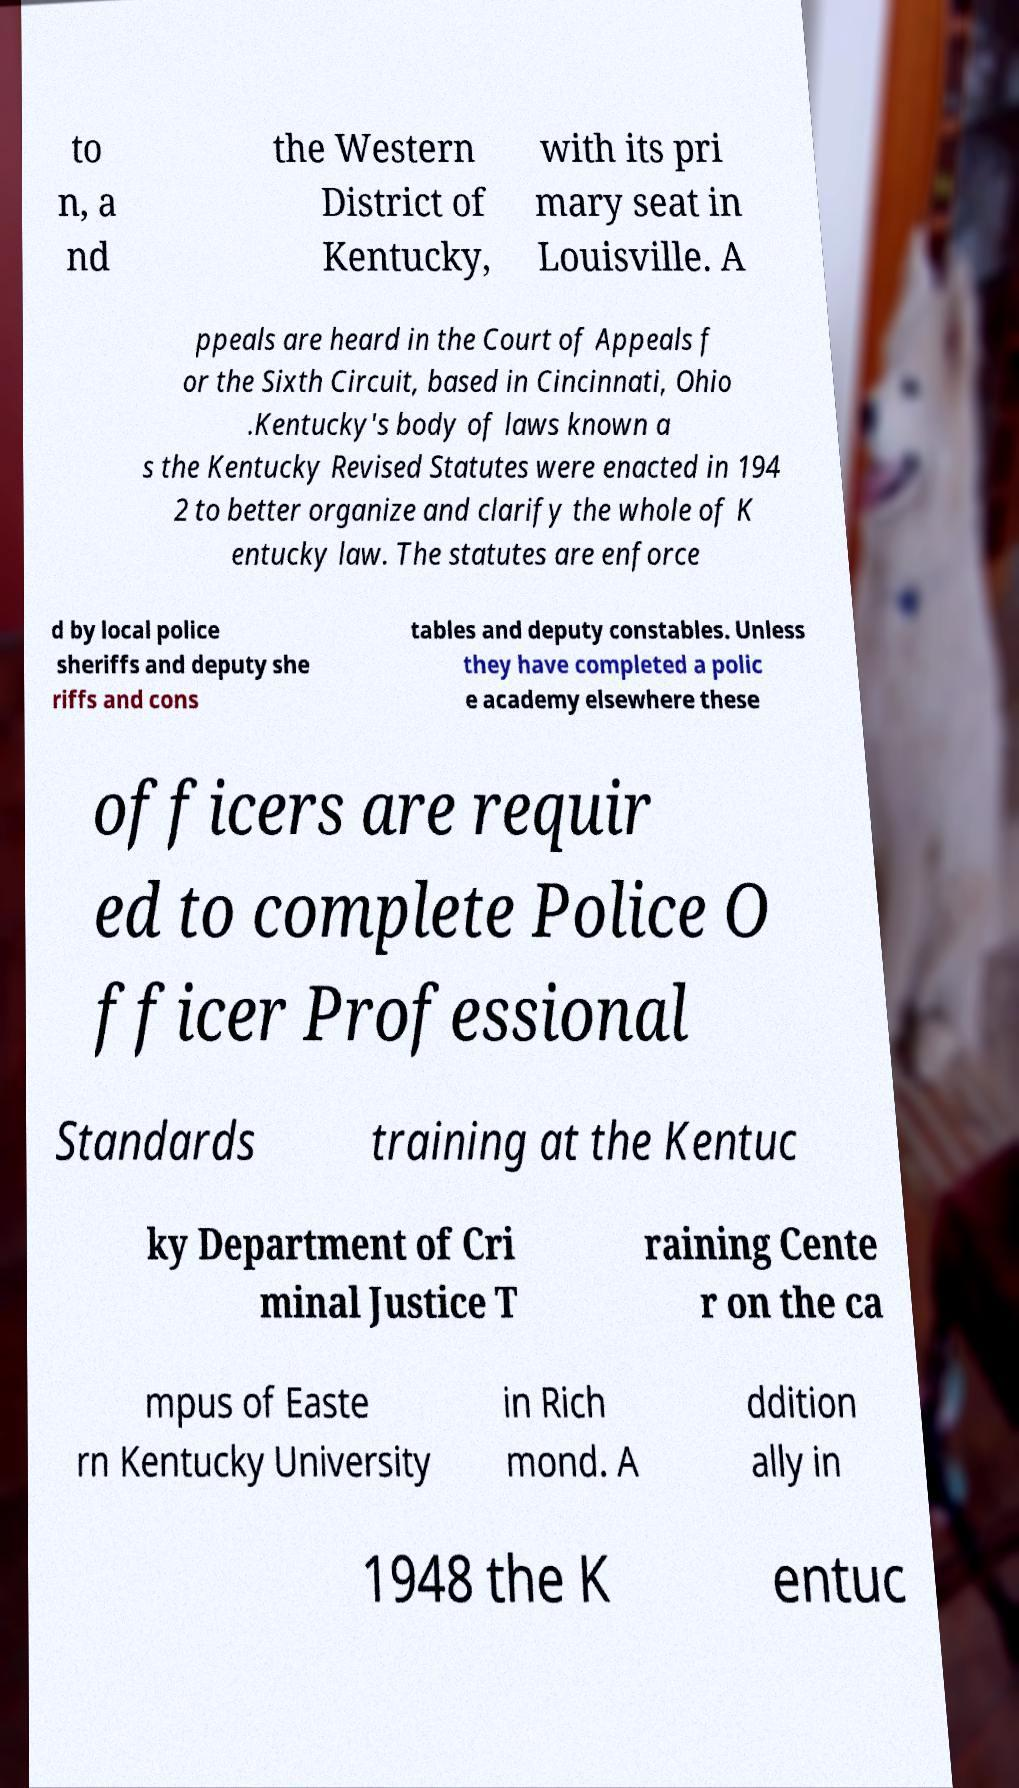I need the written content from this picture converted into text. Can you do that? to n, a nd the Western District of Kentucky, with its pri mary seat in Louisville. A ppeals are heard in the Court of Appeals f or the Sixth Circuit, based in Cincinnati, Ohio .Kentucky's body of laws known a s the Kentucky Revised Statutes were enacted in 194 2 to better organize and clarify the whole of K entucky law. The statutes are enforce d by local police sheriffs and deputy she riffs and cons tables and deputy constables. Unless they have completed a polic e academy elsewhere these officers are requir ed to complete Police O fficer Professional Standards training at the Kentuc ky Department of Cri minal Justice T raining Cente r on the ca mpus of Easte rn Kentucky University in Rich mond. A ddition ally in 1948 the K entuc 